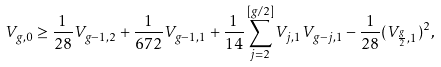Convert formula to latex. <formula><loc_0><loc_0><loc_500><loc_500>V _ { g , 0 } \geq \frac { 1 } { 2 8 } V _ { g - 1 , 2 } + \frac { 1 } { 6 7 2 } V _ { g - 1 , 1 } + \frac { 1 } { 1 4 } \sum _ { j = 2 } ^ { [ g / 2 ] } V _ { j , 1 } V _ { g - j , 1 } - \frac { 1 } { 2 8 } ( V _ { \frac { g } { 2 } , 1 } ) ^ { 2 } ,</formula> 